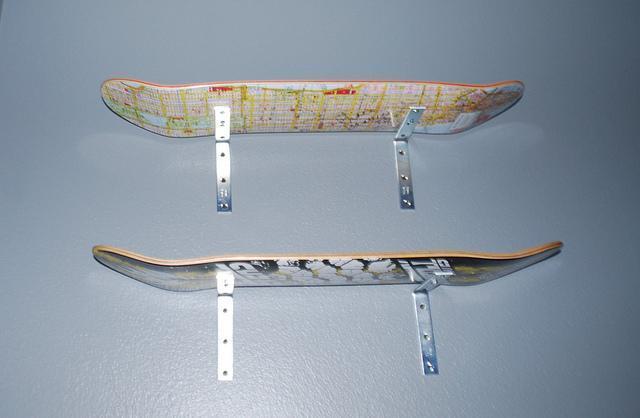How many skateboards are visible?
Give a very brief answer. 2. How many snowboards can be seen?
Give a very brief answer. 2. 